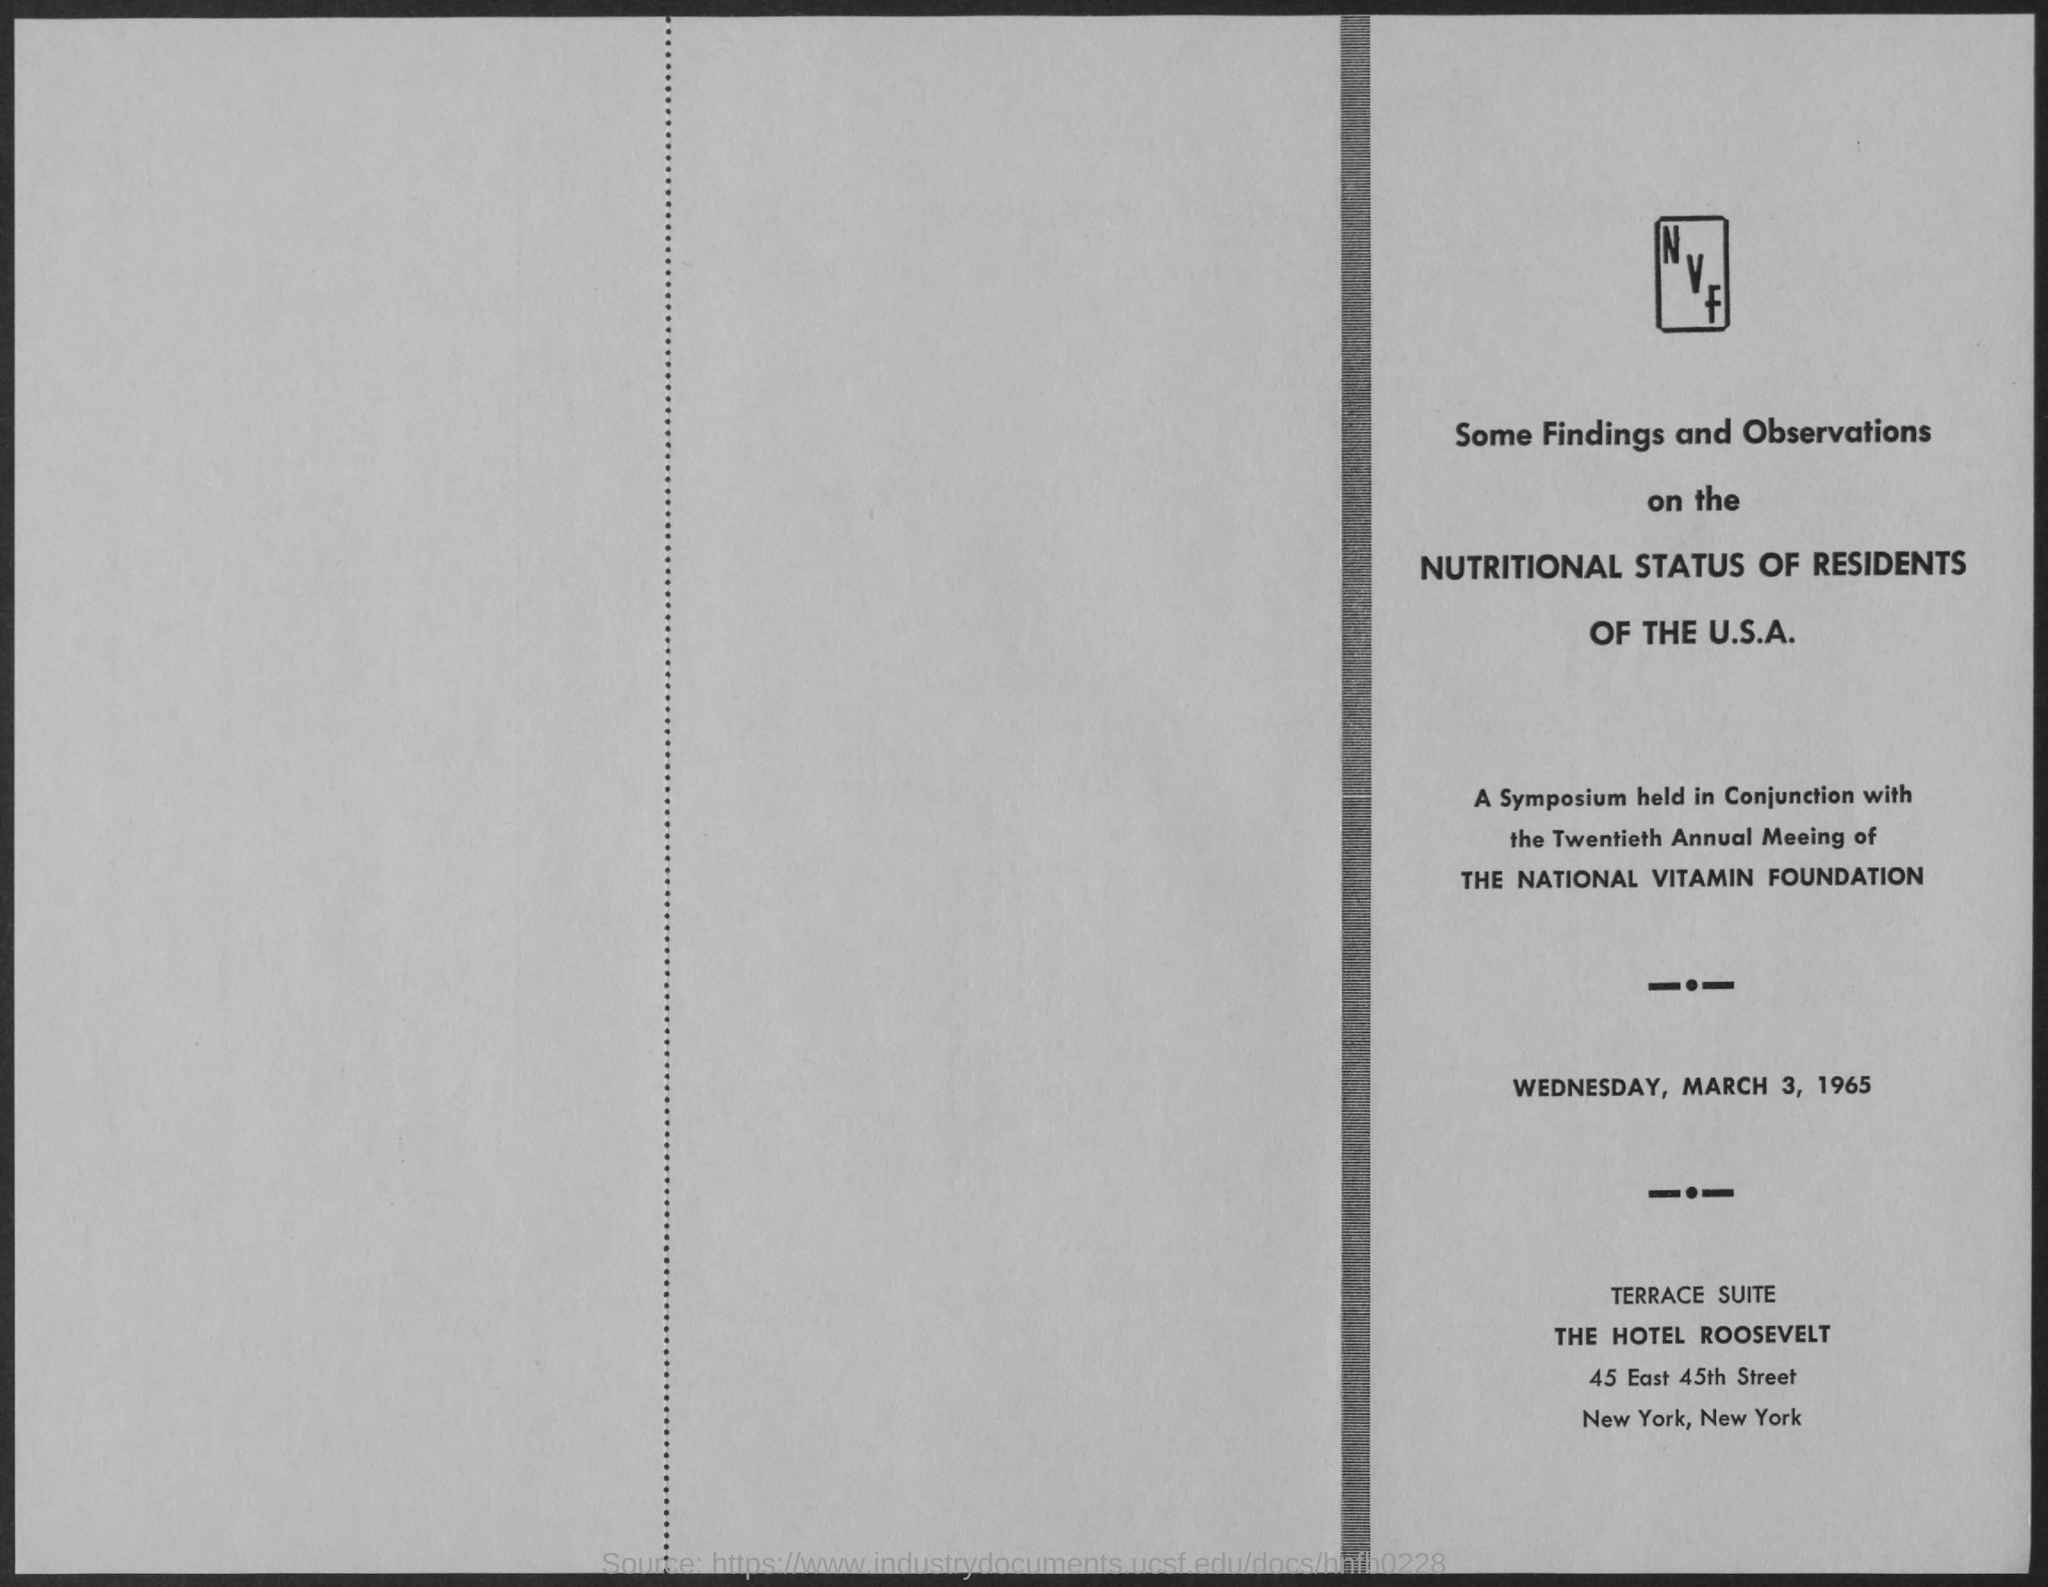Give some essential details in this illustration. The National Vitamin Foundation is named as mentioned. The name of the hotel mentioned is THE HOTEL ROOSEVELT. The Terrace Suite is a suite mentioned. The date mentioned in the given page is Wednesday, March 3, 1965. 